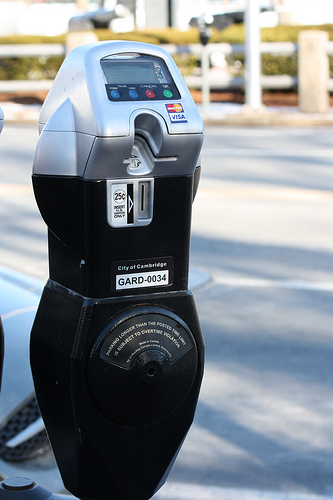Please provide the bounding box coordinate of the region this sentence describes: Credit card slot on parking meter. [0.39, 0.2, 0.55, 0.35] Please provide a short description for this region: [0.4, 0.55, 0.45, 0.57]. The letters gard on the parking meter. Please provide the bounding box coordinate of the region this sentence describes: a coin slot for quarters. [0.36, 0.35, 0.5, 0.47] Please provide the bounding box coordinate of the region this sentence describes: The sticker says VISA. [0.49, 0.19, 0.56, 0.26] Please provide a short description for this region: [0.39, 0.18, 0.44, 0.2]. The blue buttons on the meter. Please provide a short description for this region: [0.39, 0.51, 0.51, 0.57]. City of cambridge ownership tag. Please provide a short description for this region: [0.19, 0.06, 0.81, 0.23]. A distant white fence. Please provide a short description for this region: [0.37, 0.17, 0.46, 0.22]. A pair of blue dots. Please provide a short description for this region: [0.5, 0.22, 0.53, 0.24]. The visa logo on the meter. Please provide the bounding box coordinate of the region this sentence describes: a bright green circle. [0.49, 0.17, 0.52, 0.2] 